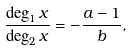Convert formula to latex. <formula><loc_0><loc_0><loc_500><loc_500>\frac { \deg _ { 1 } x } { \deg _ { 2 } x } = - \frac { a - 1 } { b } ,</formula> 